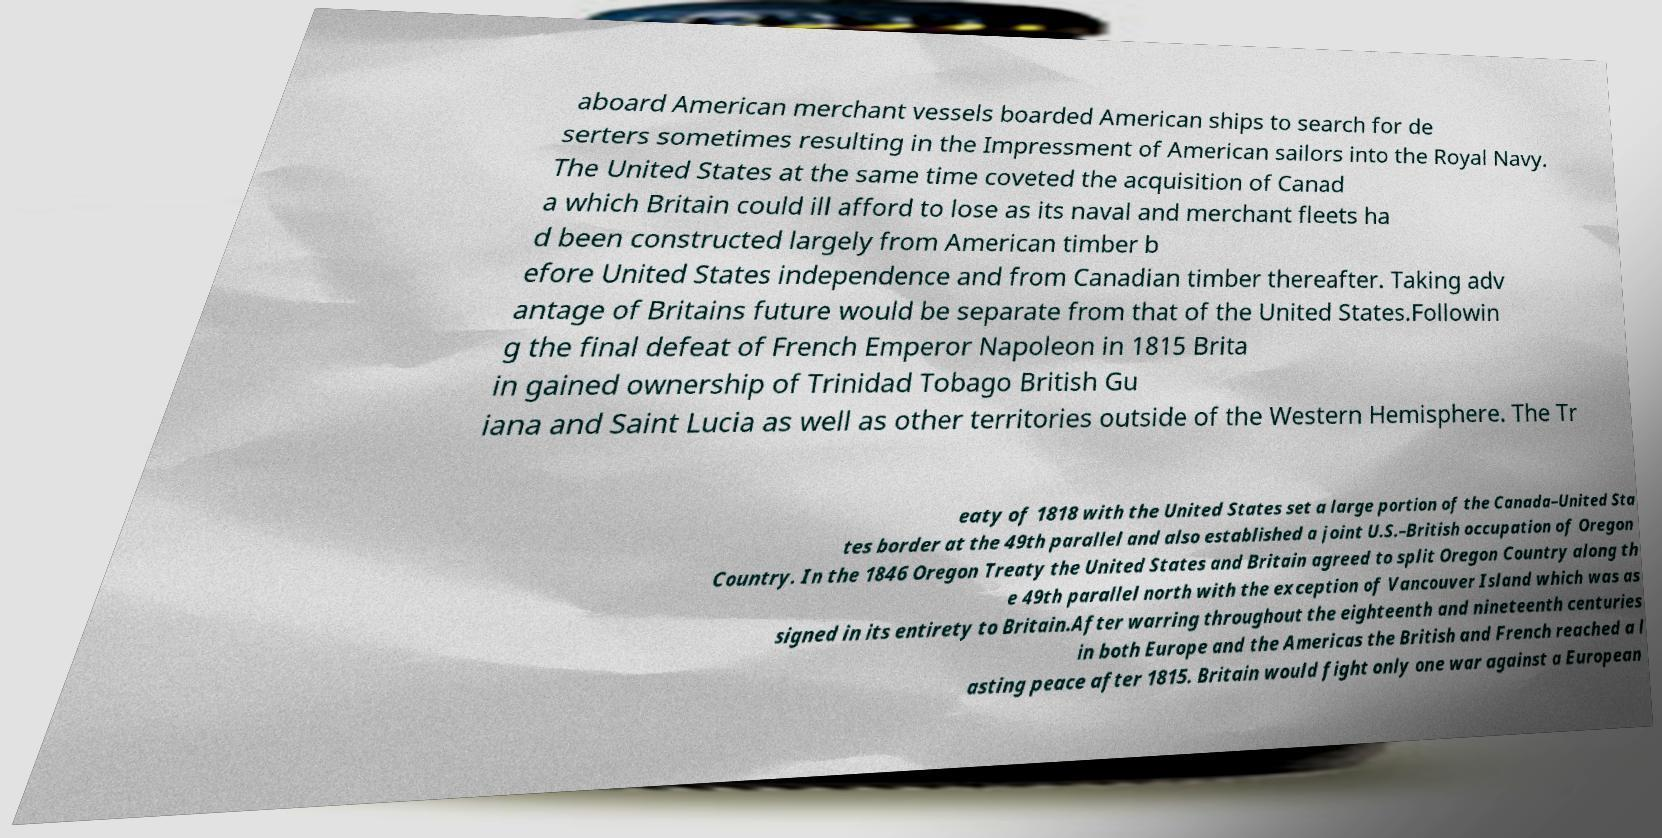What messages or text are displayed in this image? I need them in a readable, typed format. aboard American merchant vessels boarded American ships to search for de serters sometimes resulting in the Impressment of American sailors into the Royal Navy. The United States at the same time coveted the acquisition of Canad a which Britain could ill afford to lose as its naval and merchant fleets ha d been constructed largely from American timber b efore United States independence and from Canadian timber thereafter. Taking adv antage of Britains future would be separate from that of the United States.Followin g the final defeat of French Emperor Napoleon in 1815 Brita in gained ownership of Trinidad Tobago British Gu iana and Saint Lucia as well as other territories outside of the Western Hemisphere. The Tr eaty of 1818 with the United States set a large portion of the Canada–United Sta tes border at the 49th parallel and also established a joint U.S.–British occupation of Oregon Country. In the 1846 Oregon Treaty the United States and Britain agreed to split Oregon Country along th e 49th parallel north with the exception of Vancouver Island which was as signed in its entirety to Britain.After warring throughout the eighteenth and nineteenth centuries in both Europe and the Americas the British and French reached a l asting peace after 1815. Britain would fight only one war against a European 